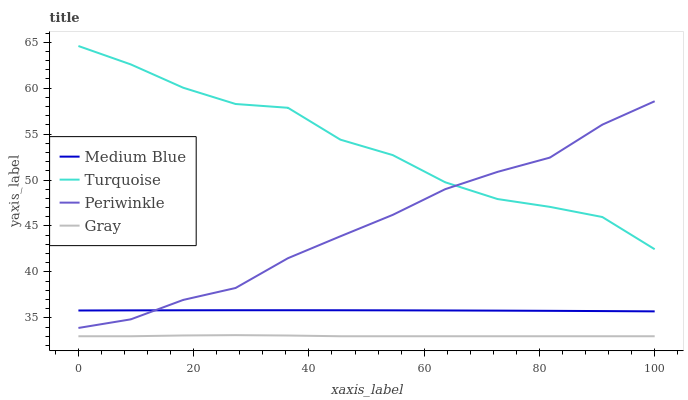Does Gray have the minimum area under the curve?
Answer yes or no. Yes. Does Turquoise have the maximum area under the curve?
Answer yes or no. Yes. Does Medium Blue have the minimum area under the curve?
Answer yes or no. No. Does Medium Blue have the maximum area under the curve?
Answer yes or no. No. Is Medium Blue the smoothest?
Answer yes or no. Yes. Is Turquoise the roughest?
Answer yes or no. Yes. Is Turquoise the smoothest?
Answer yes or no. No. Is Medium Blue the roughest?
Answer yes or no. No. Does Gray have the lowest value?
Answer yes or no. Yes. Does Medium Blue have the lowest value?
Answer yes or no. No. Does Turquoise have the highest value?
Answer yes or no. Yes. Does Medium Blue have the highest value?
Answer yes or no. No. Is Gray less than Turquoise?
Answer yes or no. Yes. Is Turquoise greater than Gray?
Answer yes or no. Yes. Does Medium Blue intersect Periwinkle?
Answer yes or no. Yes. Is Medium Blue less than Periwinkle?
Answer yes or no. No. Is Medium Blue greater than Periwinkle?
Answer yes or no. No. Does Gray intersect Turquoise?
Answer yes or no. No. 